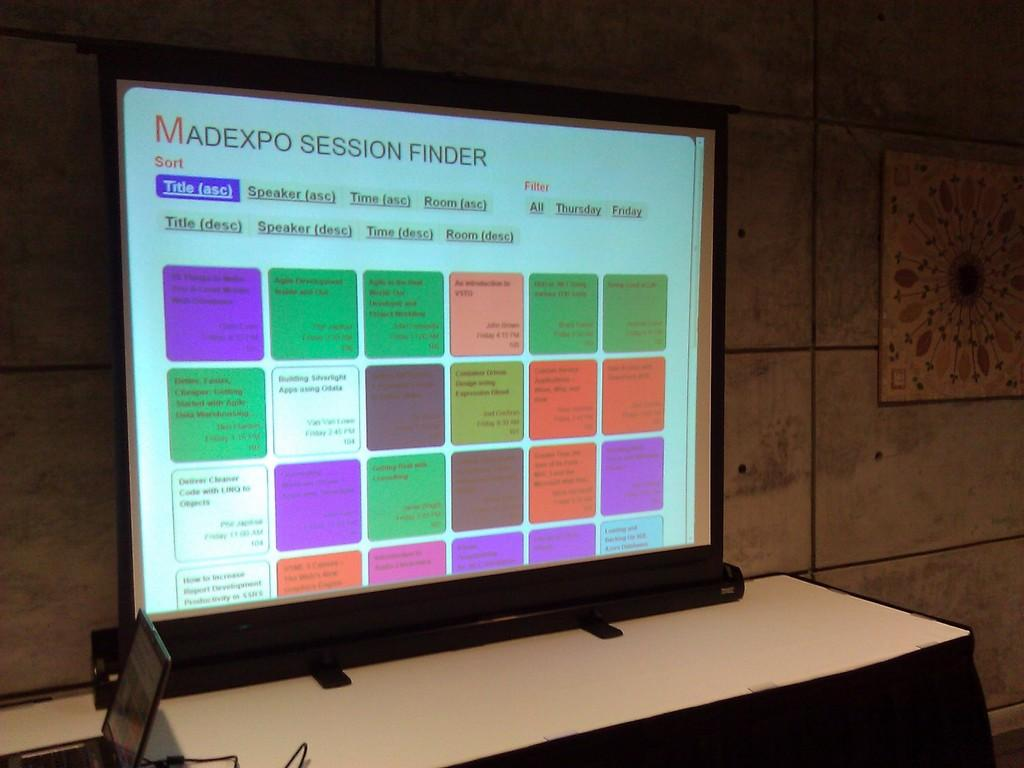What is the main object in the image? There is a screen in the image. What is located beneath the screen? There is a table in the image. What device can be seen on the table? A laptop is present on the table. What can be seen in the background of the image? There is a wall and a frame in the background of the image. What type of faucet is visible in the image? There is no faucet present in the image. What order is being followed by the people in the image? There are no people present in the image, so it is not possible to determine if an order is being followed. 